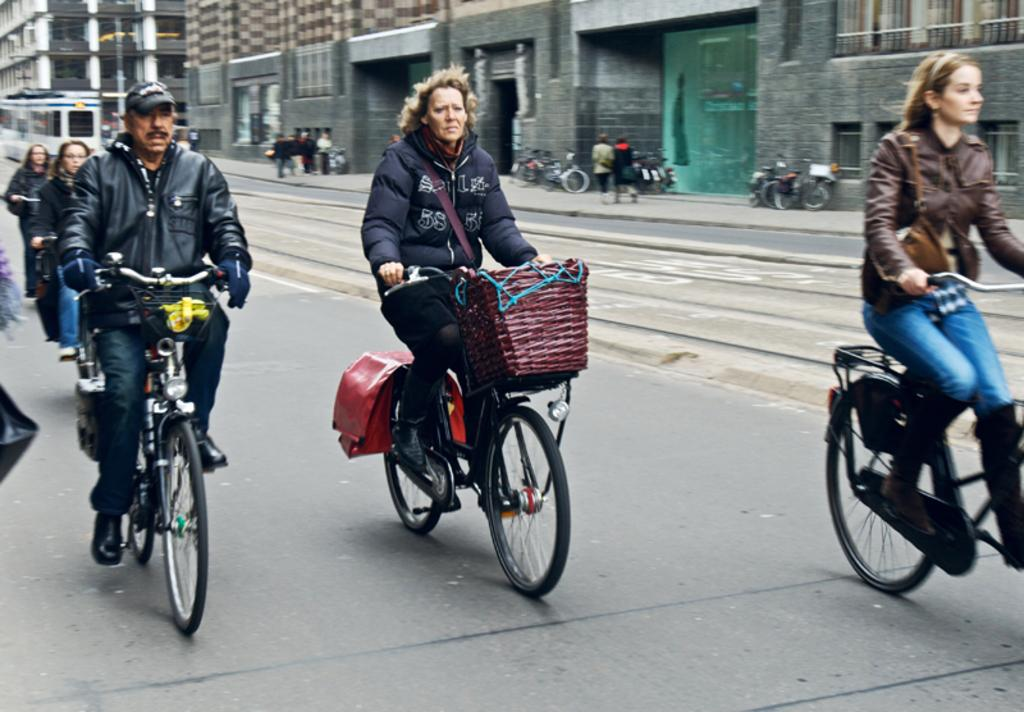What are the people in the image doing? The people in the image are riding bicycles. Where are the people riding their bicycles? The people are riding bicycles on a road. What else can be seen in the image besides the people riding bicycles? There is a building visible in the image, and bicycles are parked on the road. What type of skirt is the governor wearing in the image? There is no governor or skirt present in the image. The image features people riding bicycles on a road, with a building and parked bicycles visible. 